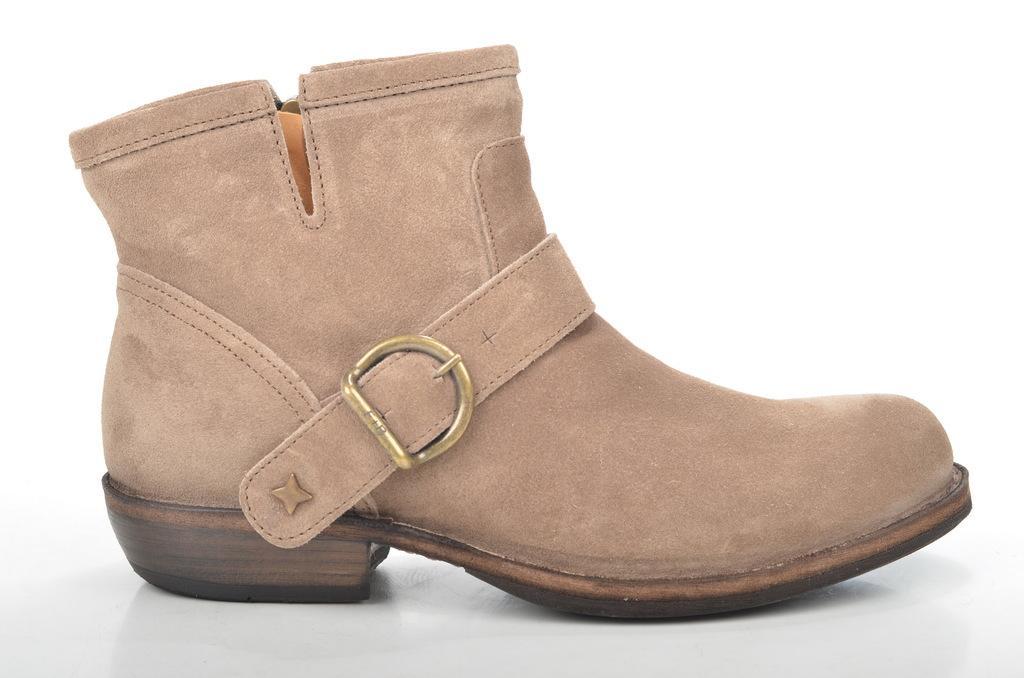In one or two sentences, can you explain what this image depicts? In the center of the image we can see a boot. 